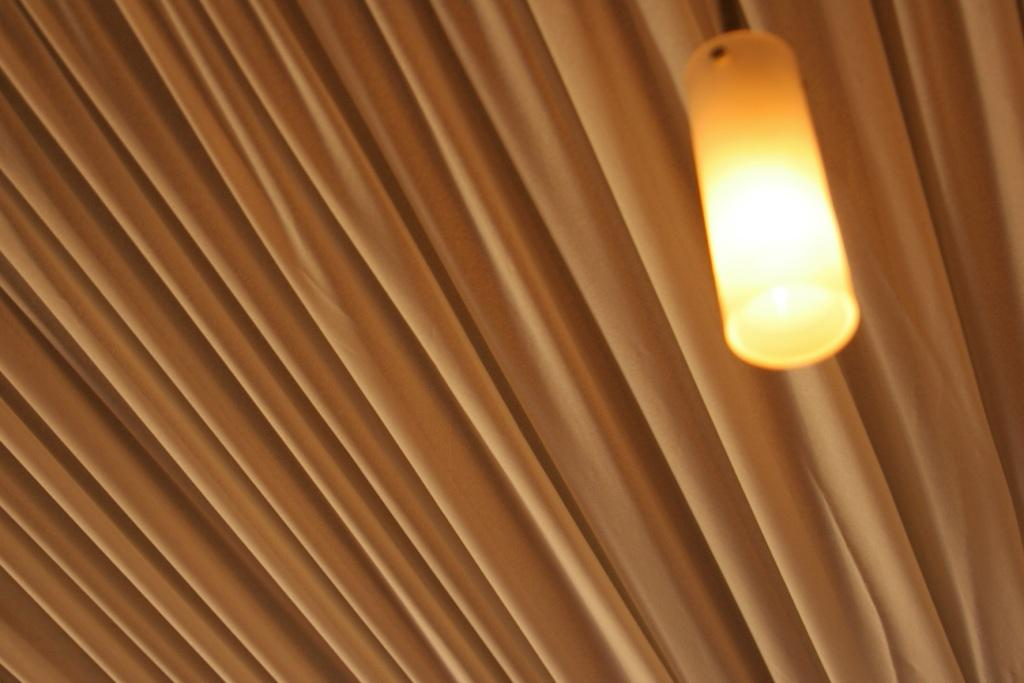What type of window treatment is visible in the image? There is a curtain in the image. What type of lighting is present in the image? There is a lamp in the image. How many cherries are on the knife in the image? There is no knife or cherries present in the image. What type of coach is visible in the image? There is no coach present in the image. 